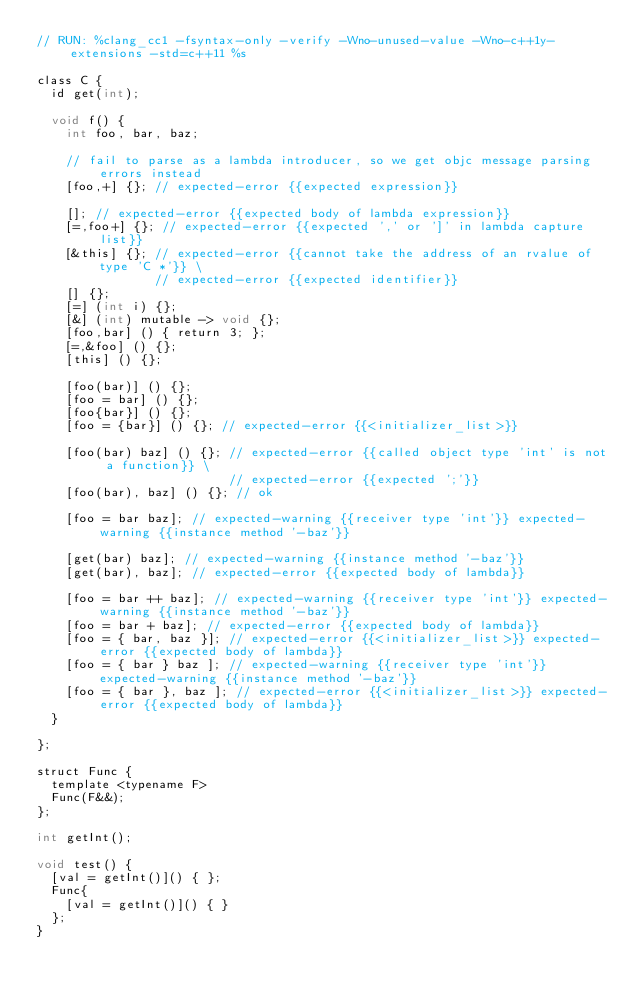<code> <loc_0><loc_0><loc_500><loc_500><_ObjectiveC_>// RUN: %clang_cc1 -fsyntax-only -verify -Wno-unused-value -Wno-c++1y-extensions -std=c++11 %s

class C {
  id get(int);

  void f() {
    int foo, bar, baz;

    // fail to parse as a lambda introducer, so we get objc message parsing errors instead
    [foo,+] {}; // expected-error {{expected expression}}

    []; // expected-error {{expected body of lambda expression}}
    [=,foo+] {}; // expected-error {{expected ',' or ']' in lambda capture list}}
    [&this] {}; // expected-error {{cannot take the address of an rvalue of type 'C *'}} \
                // expected-error {{expected identifier}}
    [] {}; 
    [=] (int i) {}; 
    [&] (int) mutable -> void {}; 
    [foo,bar] () { return 3; }; 
    [=,&foo] () {}; 
    [this] () {}; 

    [foo(bar)] () {};
    [foo = bar] () {};
    [foo{bar}] () {};
    [foo = {bar}] () {}; // expected-error {{<initializer_list>}}

    [foo(bar) baz] () {}; // expected-error {{called object type 'int' is not a function}} \
                          // expected-error {{expected ';'}}
    [foo(bar), baz] () {}; // ok

    [foo = bar baz]; // expected-warning {{receiver type 'int'}} expected-warning {{instance method '-baz'}}

    [get(bar) baz]; // expected-warning {{instance method '-baz'}}
    [get(bar), baz]; // expected-error {{expected body of lambda}}

    [foo = bar ++ baz]; // expected-warning {{receiver type 'int'}} expected-warning {{instance method '-baz'}}
    [foo = bar + baz]; // expected-error {{expected body of lambda}}
    [foo = { bar, baz }]; // expected-error {{<initializer_list>}} expected-error {{expected body of lambda}}
    [foo = { bar } baz ]; // expected-warning {{receiver type 'int'}} expected-warning {{instance method '-baz'}}
    [foo = { bar }, baz ]; // expected-error {{<initializer_list>}} expected-error {{expected body of lambda}}
  }

};

struct Func {
  template <typename F>
  Func(F&&);
};

int getInt();

void test() {
  [val = getInt()]() { };
  Func{
    [val = getInt()]() { }
  };
}
</code> 